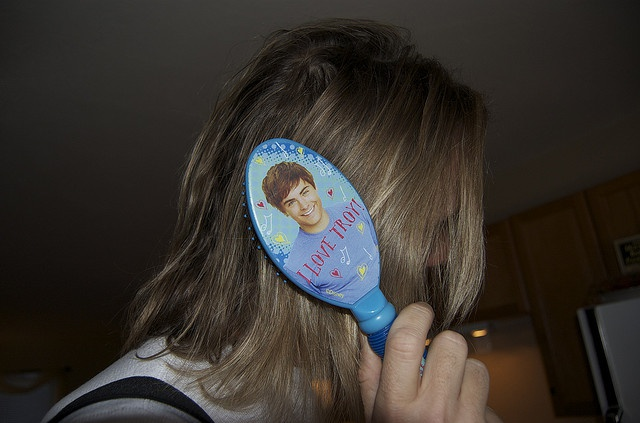Describe the objects in this image and their specific colors. I can see people in black and gray tones in this image. 